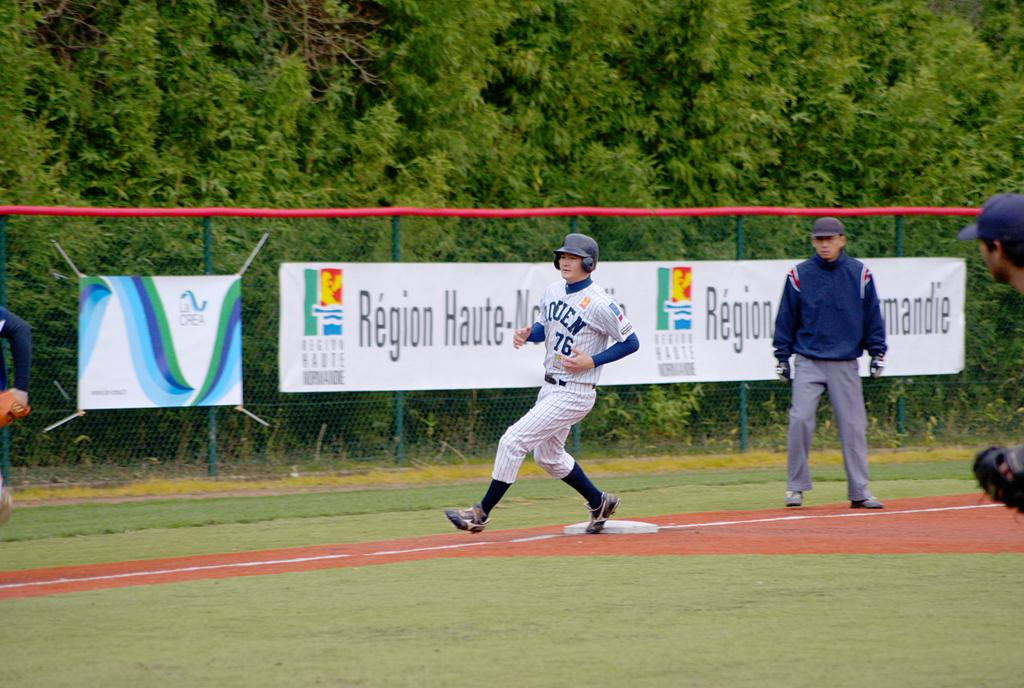What are the persons in the image doing? The persons in the image are standing and running. What can be seen in the background of the image? There are banners with text, a fence, and trees in the background of the image. How many toes can be seen on the beggar in the image? There is no beggar present in the image, so it is not possible to determine the number of toes visible. 